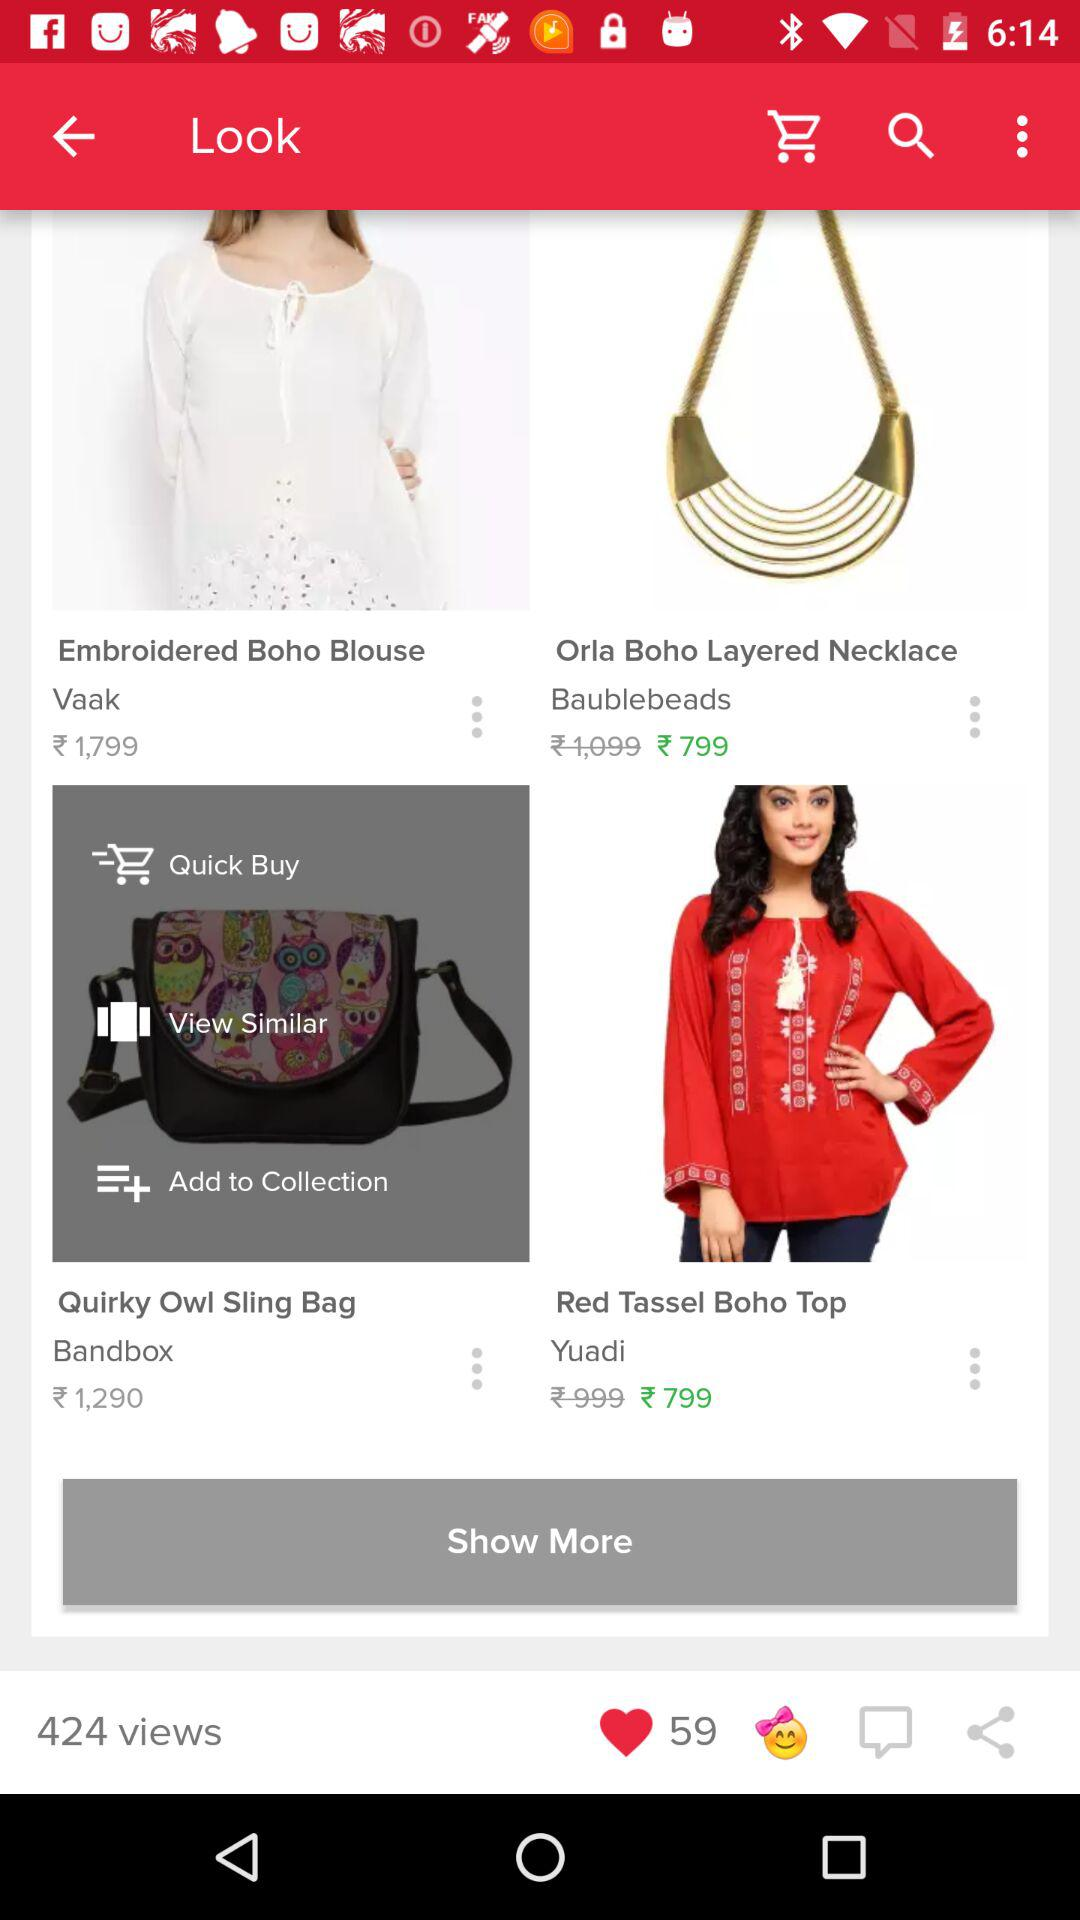What is the price of the "Embroidered Boho Blouse"? The price of the "Embroidered Boho Blouse" is 1,799 rupees. 